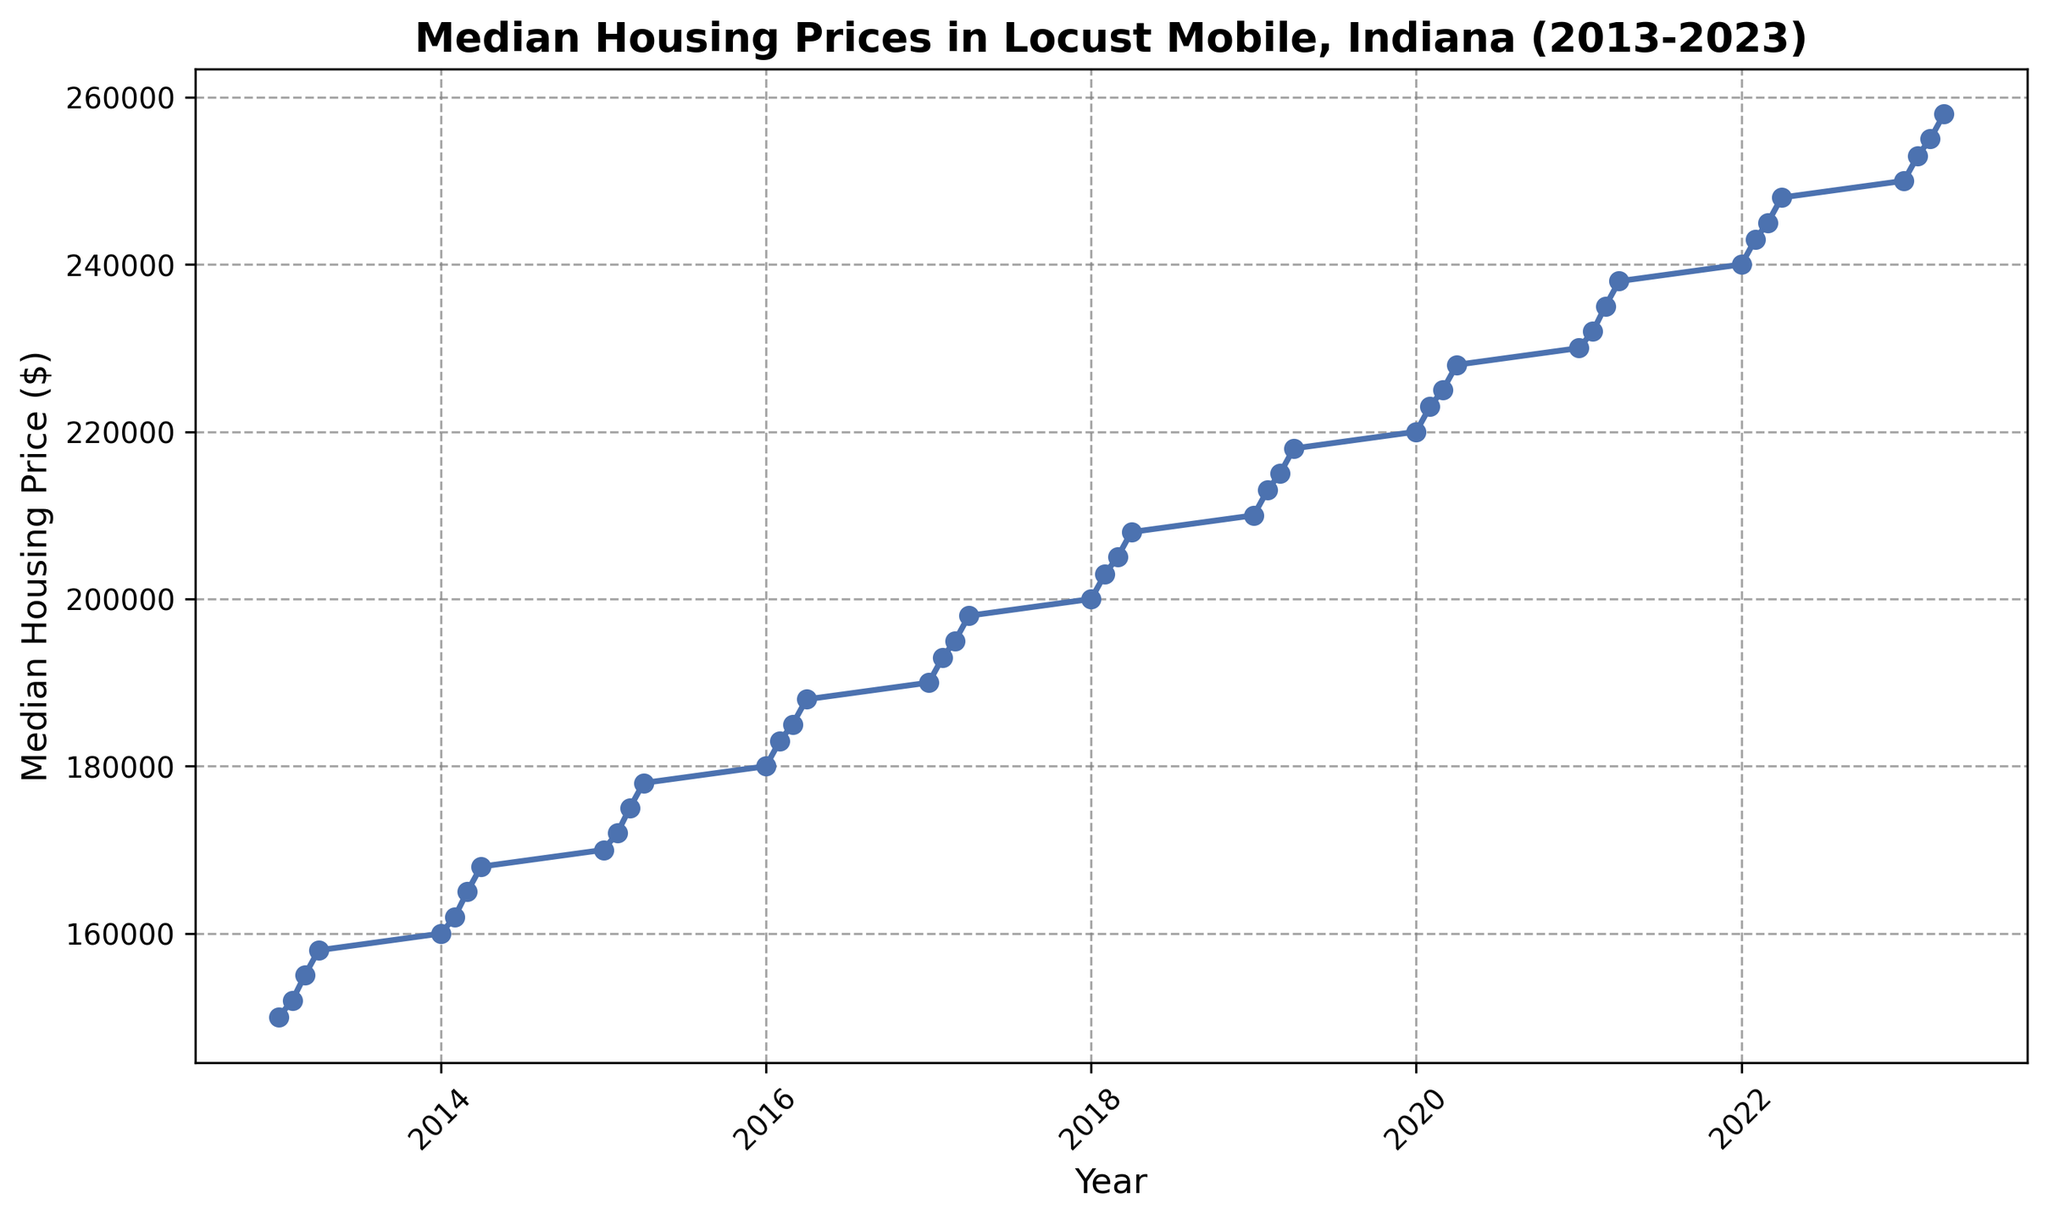Which year had the highest median housing price in Q4? To find the highest median housing price in Q4, check each year's Q4 data point from 2013 to 2022 and compare their values. The year 2023 Q4 data shows the highest price at $258,000.
Answer: 2023 What’s the median housing price in Q2 of 2020? Identify the point corresponding to Q2 in the year 2020 from the plot. This value is $223,000.
Answer: $223,000 Compare the median housing prices between 2015 and 2016. Which year had a higher Q3 value? Extract the median housing prices for Q3 of both years. The Q3 value for 2015 is $175,000, and for 2016, it's $185,000, making 2016 higher.
Answer: 2016 What is the average median housing price for the year 2019? Calculate the average of the four quarterly values: (210,000 + 213,000 + 215,000 + 218,000) / 4. Sum the values to get 856,000 and then divide by 4 to obtain 214,000.
Answer: $214,000 Which quarter in 2021 experienced the largest increase in median price compared to the previous quarter? Calculate the difference in median prices between each consecutive quarter of 2021. The differences are Q2-Q1 ($232,000 - $230,000 = $2,000), Q3-Q2 ($235,000 - $232,000 = $3,000), and Q4-Q3 ($238,000 - $235,000 = $3,000). The largest increase happens in Q3 and Q4, both increased by $3000 from the previous quarter.
Answer: Q3, Q4 Does the trend of median housing prices show any period of stagnation or decrease? Review each segment of the plot line to check for any flat lines (stagnation) or downward slopes (decrease). The plot shows a steady increase with no periods of stagnation or visible decrease over the decade.
Answer: No What is the total increase in median housing price from Q1 2015 to Q4 2018? Find the median housing prices for Q1 2015 and Q4 2018 (170,000 and 208,000 respectively). The total increase is $208,000 - $170,000 = $38,000.
Answer: $38,000 During which quarter and year did the median housing price first reach $200,000? Locate the first point on the plot where the median housing price hits $200,000. This happens in Q1 2018.
Answer: Q1 2018 How does the median housing price in Q2 2014 compare to Q2 2022? Check the Q2 values for both years. In Q2 2014, the median housing price is $162,000, and in Q2 2022, it is $243,000. Hence, Q2 2022 is significantly higher.
Answer: Q2 2022 How has the growth rate of median housing prices changed over the years? Examine the slopes of the line segments. Early years show gradual increases, but the slope appears steeper in more recent years, indicating a faster growth rate.
Answer: Faster growth in recent years 